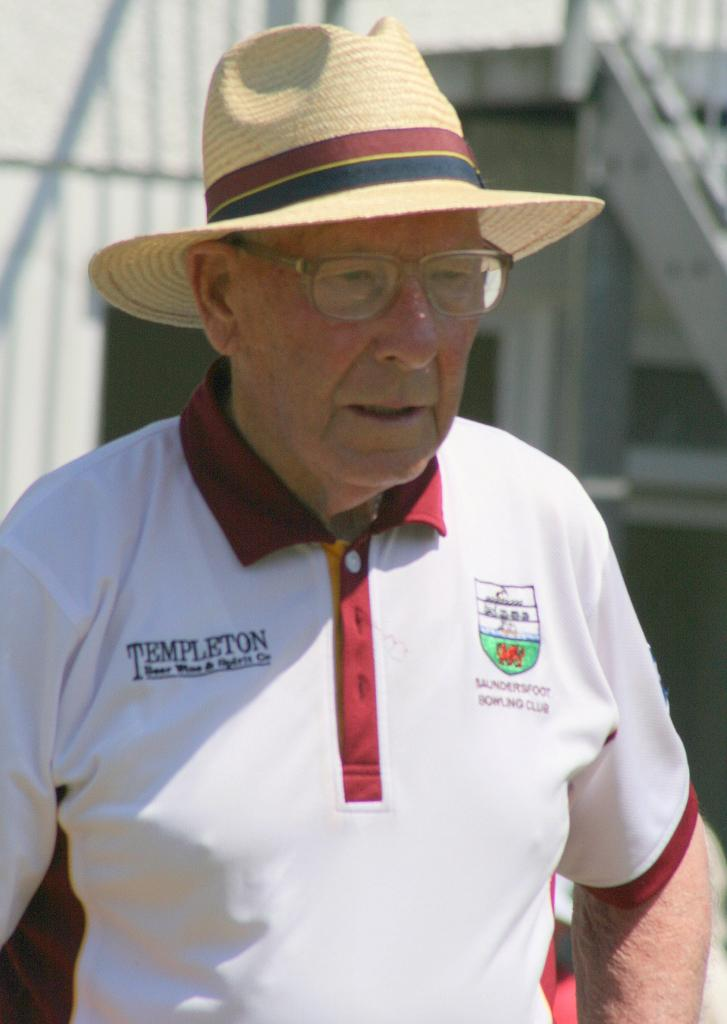Provide a one-sentence caption for the provided image. An older man wearing a sunhat, glasses, and a white polo shirt that says Templeton. 